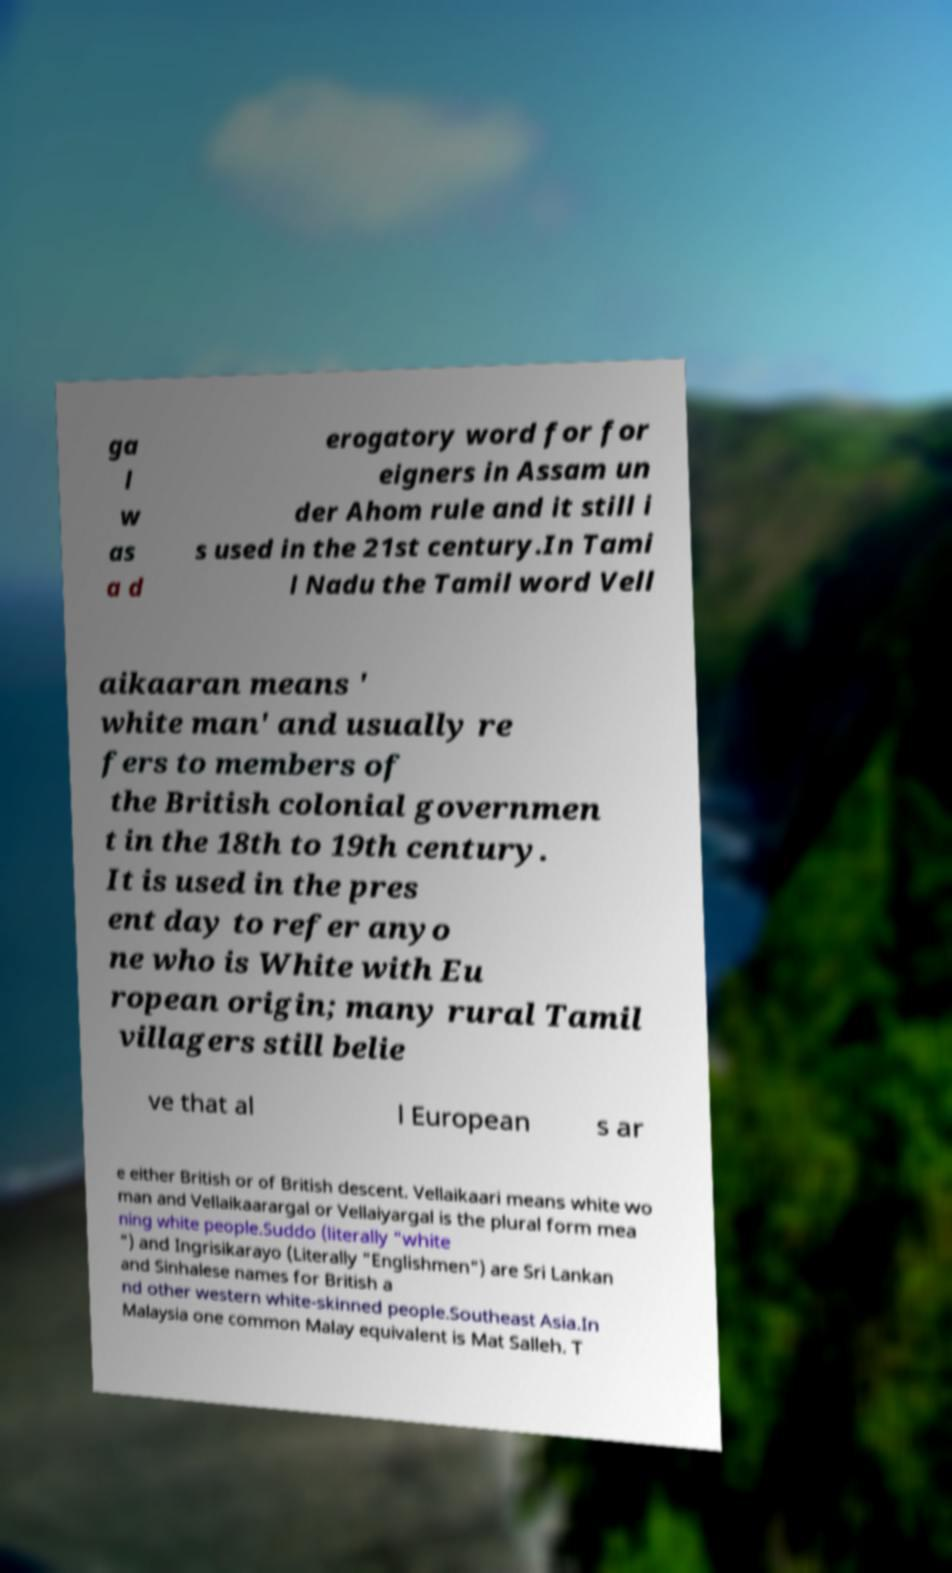Could you extract and type out the text from this image? ga l w as a d erogatory word for for eigners in Assam un der Ahom rule and it still i s used in the 21st century.In Tami l Nadu the Tamil word Vell aikaaran means ' white man' and usually re fers to members of the British colonial governmen t in the 18th to 19th century. It is used in the pres ent day to refer anyo ne who is White with Eu ropean origin; many rural Tamil villagers still belie ve that al l European s ar e either British or of British descent. Vellaikaari means white wo man and Vellaikaarargal or Vellaiyargal is the plural form mea ning white people.Suddo (literally "white ") and Ingrisikarayo (Literally "Englishmen") are Sri Lankan and Sinhalese names for British a nd other western white-skinned people.Southeast Asia.In Malaysia one common Malay equivalent is Mat Salleh. T 